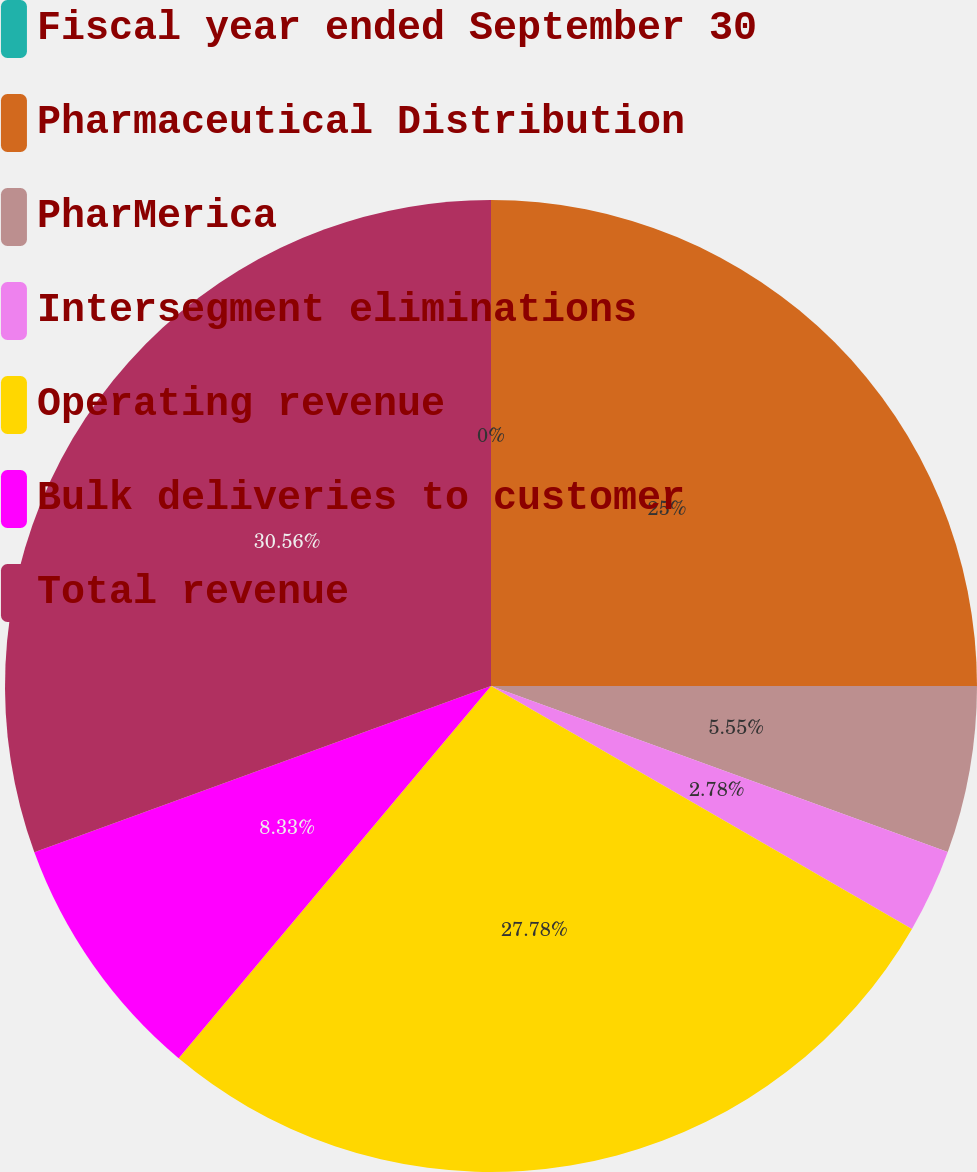<chart> <loc_0><loc_0><loc_500><loc_500><pie_chart><fcel>Fiscal year ended September 30<fcel>Pharmaceutical Distribution<fcel>PharMerica<fcel>Intersegment eliminations<fcel>Operating revenue<fcel>Bulk deliveries to customer<fcel>Total revenue<nl><fcel>0.0%<fcel>25.0%<fcel>5.55%<fcel>2.78%<fcel>27.78%<fcel>8.33%<fcel>30.56%<nl></chart> 